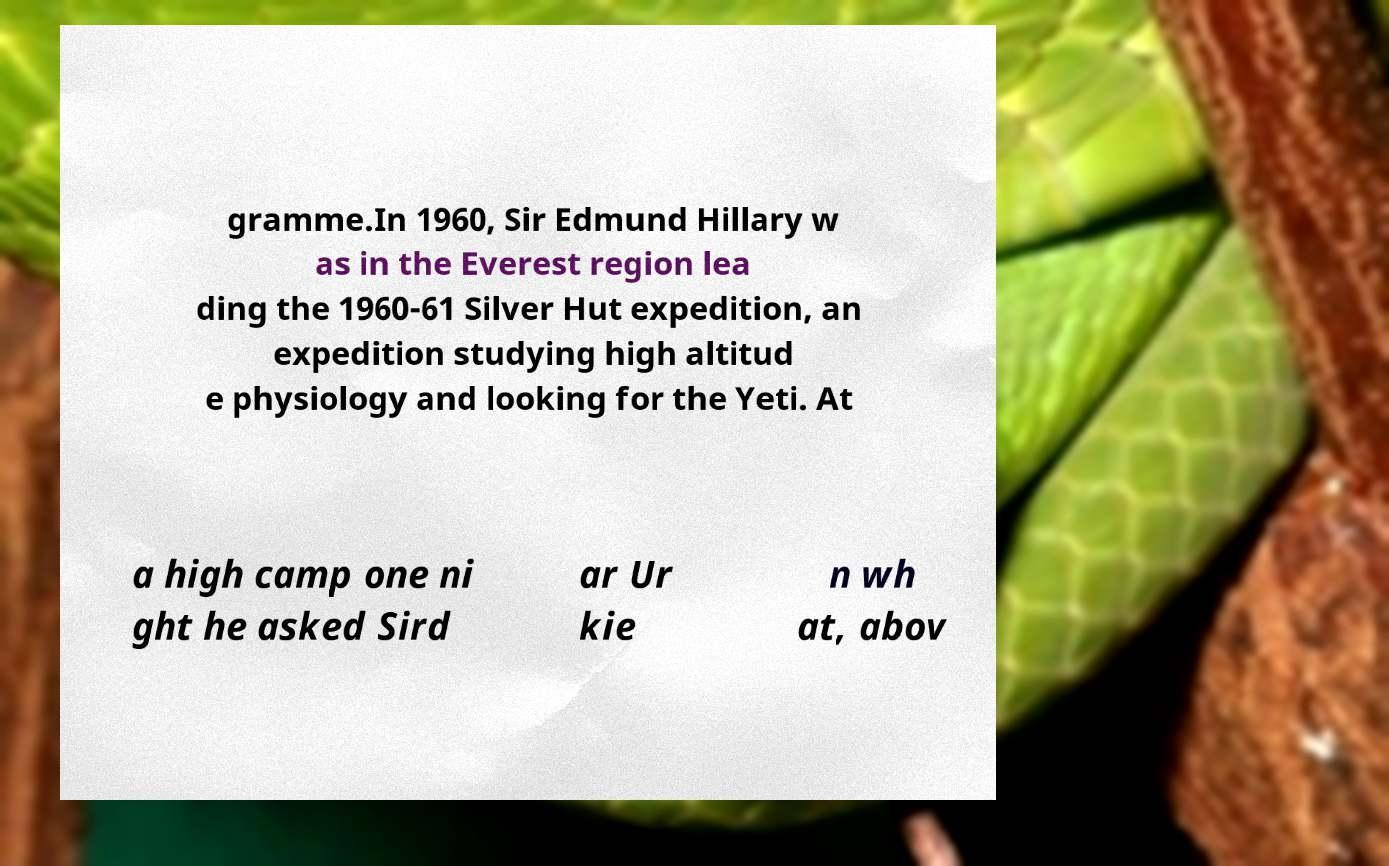Please identify and transcribe the text found in this image. gramme.In 1960, Sir Edmund Hillary w as in the Everest region lea ding the 1960-61 Silver Hut expedition, an expedition studying high altitud e physiology and looking for the Yeti. At a high camp one ni ght he asked Sird ar Ur kie n wh at, abov 